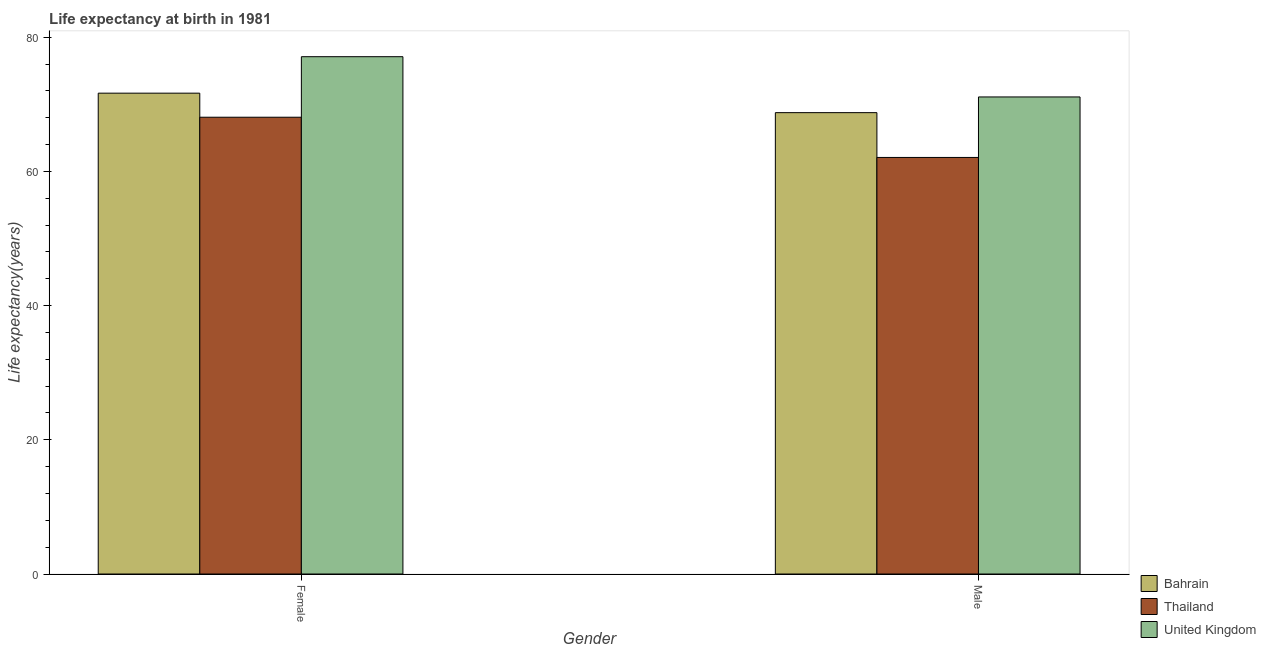Are the number of bars per tick equal to the number of legend labels?
Offer a very short reply. Yes. Are the number of bars on each tick of the X-axis equal?
Keep it short and to the point. Yes. How many bars are there on the 1st tick from the left?
Offer a very short reply. 3. How many bars are there on the 2nd tick from the right?
Ensure brevity in your answer.  3. What is the life expectancy(female) in Thailand?
Ensure brevity in your answer.  68.08. Across all countries, what is the maximum life expectancy(male)?
Keep it short and to the point. 71.1. Across all countries, what is the minimum life expectancy(female)?
Provide a succinct answer. 68.08. In which country was the life expectancy(male) maximum?
Your response must be concise. United Kingdom. In which country was the life expectancy(male) minimum?
Make the answer very short. Thailand. What is the total life expectancy(female) in the graph?
Make the answer very short. 216.84. What is the difference between the life expectancy(male) in Thailand and that in United Kingdom?
Ensure brevity in your answer.  -9.02. What is the difference between the life expectancy(female) in United Kingdom and the life expectancy(male) in Thailand?
Your answer should be compact. 15.02. What is the average life expectancy(female) per country?
Your answer should be compact. 72.28. What is the difference between the life expectancy(male) and life expectancy(female) in Thailand?
Your response must be concise. -6. What is the ratio of the life expectancy(female) in Thailand to that in United Kingdom?
Offer a very short reply. 0.88. In how many countries, is the life expectancy(female) greater than the average life expectancy(female) taken over all countries?
Your answer should be compact. 1. What does the 1st bar from the left in Male represents?
Ensure brevity in your answer.  Bahrain. What does the 3rd bar from the right in Female represents?
Your response must be concise. Bahrain. How many bars are there?
Provide a succinct answer. 6. Are all the bars in the graph horizontal?
Your response must be concise. No. How many countries are there in the graph?
Ensure brevity in your answer.  3. What is the difference between two consecutive major ticks on the Y-axis?
Keep it short and to the point. 20. Does the graph contain any zero values?
Give a very brief answer. No. Does the graph contain grids?
Your response must be concise. No. Where does the legend appear in the graph?
Keep it short and to the point. Bottom right. How many legend labels are there?
Ensure brevity in your answer.  3. What is the title of the graph?
Provide a succinct answer. Life expectancy at birth in 1981. What is the label or title of the Y-axis?
Provide a succinct answer. Life expectancy(years). What is the Life expectancy(years) of Bahrain in Female?
Give a very brief answer. 71.66. What is the Life expectancy(years) in Thailand in Female?
Your response must be concise. 68.08. What is the Life expectancy(years) of United Kingdom in Female?
Your answer should be compact. 77.1. What is the Life expectancy(years) of Bahrain in Male?
Offer a terse response. 68.76. What is the Life expectancy(years) in Thailand in Male?
Your answer should be very brief. 62.08. What is the Life expectancy(years) of United Kingdom in Male?
Provide a succinct answer. 71.1. Across all Gender, what is the maximum Life expectancy(years) of Bahrain?
Your answer should be compact. 71.66. Across all Gender, what is the maximum Life expectancy(years) in Thailand?
Keep it short and to the point. 68.08. Across all Gender, what is the maximum Life expectancy(years) of United Kingdom?
Provide a succinct answer. 77.1. Across all Gender, what is the minimum Life expectancy(years) in Bahrain?
Your response must be concise. 68.76. Across all Gender, what is the minimum Life expectancy(years) in Thailand?
Give a very brief answer. 62.08. Across all Gender, what is the minimum Life expectancy(years) of United Kingdom?
Offer a very short reply. 71.1. What is the total Life expectancy(years) of Bahrain in the graph?
Make the answer very short. 140.42. What is the total Life expectancy(years) in Thailand in the graph?
Your response must be concise. 130.16. What is the total Life expectancy(years) in United Kingdom in the graph?
Provide a short and direct response. 148.2. What is the difference between the Life expectancy(years) of Bahrain in Female and that in Male?
Offer a very short reply. 2.9. What is the difference between the Life expectancy(years) in Thailand in Female and that in Male?
Offer a very short reply. 6. What is the difference between the Life expectancy(years) of United Kingdom in Female and that in Male?
Your response must be concise. 6. What is the difference between the Life expectancy(years) in Bahrain in Female and the Life expectancy(years) in Thailand in Male?
Your response must be concise. 9.58. What is the difference between the Life expectancy(years) in Bahrain in Female and the Life expectancy(years) in United Kingdom in Male?
Make the answer very short. 0.56. What is the difference between the Life expectancy(years) of Thailand in Female and the Life expectancy(years) of United Kingdom in Male?
Your response must be concise. -3.02. What is the average Life expectancy(years) in Bahrain per Gender?
Your response must be concise. 70.21. What is the average Life expectancy(years) of Thailand per Gender?
Keep it short and to the point. 65.08. What is the average Life expectancy(years) in United Kingdom per Gender?
Your response must be concise. 74.1. What is the difference between the Life expectancy(years) of Bahrain and Life expectancy(years) of Thailand in Female?
Provide a succinct answer. 3.59. What is the difference between the Life expectancy(years) in Bahrain and Life expectancy(years) in United Kingdom in Female?
Provide a succinct answer. -5.44. What is the difference between the Life expectancy(years) in Thailand and Life expectancy(years) in United Kingdom in Female?
Offer a very short reply. -9.02. What is the difference between the Life expectancy(years) in Bahrain and Life expectancy(years) in Thailand in Male?
Offer a terse response. 6.68. What is the difference between the Life expectancy(years) in Bahrain and Life expectancy(years) in United Kingdom in Male?
Give a very brief answer. -2.34. What is the difference between the Life expectancy(years) in Thailand and Life expectancy(years) in United Kingdom in Male?
Ensure brevity in your answer.  -9.02. What is the ratio of the Life expectancy(years) in Bahrain in Female to that in Male?
Give a very brief answer. 1.04. What is the ratio of the Life expectancy(years) of Thailand in Female to that in Male?
Provide a succinct answer. 1.1. What is the ratio of the Life expectancy(years) of United Kingdom in Female to that in Male?
Provide a short and direct response. 1.08. What is the difference between the highest and the second highest Life expectancy(years) of Bahrain?
Your answer should be very brief. 2.9. What is the difference between the highest and the second highest Life expectancy(years) of Thailand?
Offer a very short reply. 6. What is the difference between the highest and the lowest Life expectancy(years) of Bahrain?
Offer a terse response. 2.9. What is the difference between the highest and the lowest Life expectancy(years) in Thailand?
Your response must be concise. 6. What is the difference between the highest and the lowest Life expectancy(years) in United Kingdom?
Give a very brief answer. 6. 